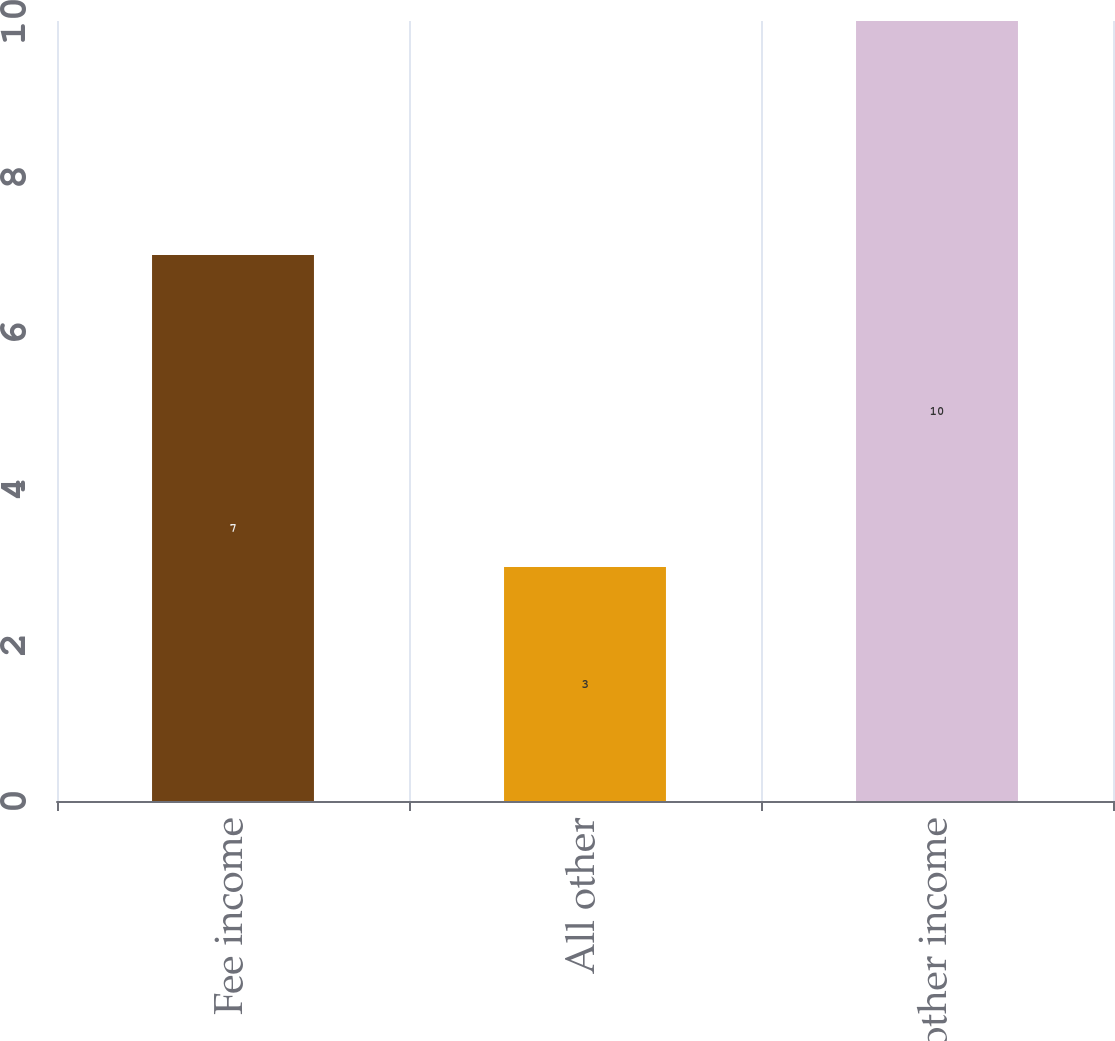Convert chart. <chart><loc_0><loc_0><loc_500><loc_500><bar_chart><fcel>Fee income<fcel>All other<fcel>Total other income<nl><fcel>7<fcel>3<fcel>10<nl></chart> 